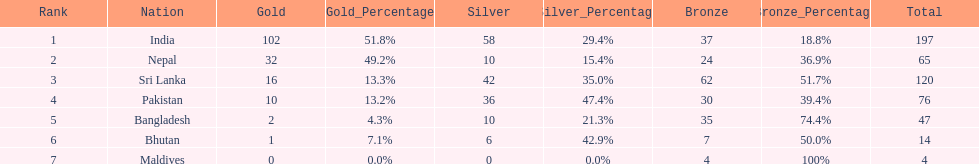What country has won no silver medals? Maldives. 